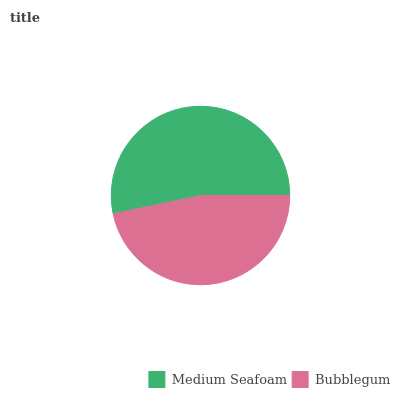Is Bubblegum the minimum?
Answer yes or no. Yes. Is Medium Seafoam the maximum?
Answer yes or no. Yes. Is Bubblegum the maximum?
Answer yes or no. No. Is Medium Seafoam greater than Bubblegum?
Answer yes or no. Yes. Is Bubblegum less than Medium Seafoam?
Answer yes or no. Yes. Is Bubblegum greater than Medium Seafoam?
Answer yes or no. No. Is Medium Seafoam less than Bubblegum?
Answer yes or no. No. Is Medium Seafoam the high median?
Answer yes or no. Yes. Is Bubblegum the low median?
Answer yes or no. Yes. Is Bubblegum the high median?
Answer yes or no. No. Is Medium Seafoam the low median?
Answer yes or no. No. 